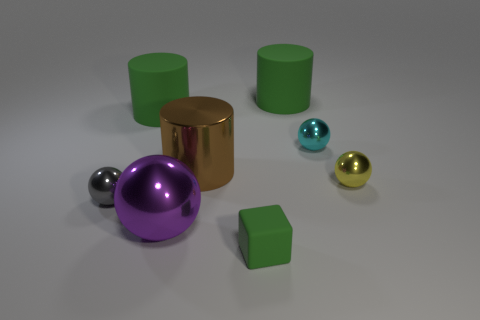Do the small rubber thing and the large metal cylinder have the same color?
Provide a succinct answer. No. There is a cyan object that is the same shape as the big purple metal object; what material is it?
Give a very brief answer. Metal. Is there any other thing that has the same material as the purple thing?
Your response must be concise. Yes. Are there an equal number of small green rubber cubes left of the gray object and cyan metal things in front of the big purple thing?
Provide a short and direct response. Yes. Does the large purple object have the same material as the small green object?
Offer a terse response. No. What number of yellow things are cubes or large objects?
Your answer should be compact. 0. What number of green matte things are the same shape as the big purple metallic thing?
Your response must be concise. 0. What is the material of the brown cylinder?
Keep it short and to the point. Metal. Is the number of shiny spheres in front of the cyan object the same as the number of cyan shiny balls?
Give a very brief answer. No. What is the shape of the cyan thing that is the same size as the gray object?
Make the answer very short. Sphere. 